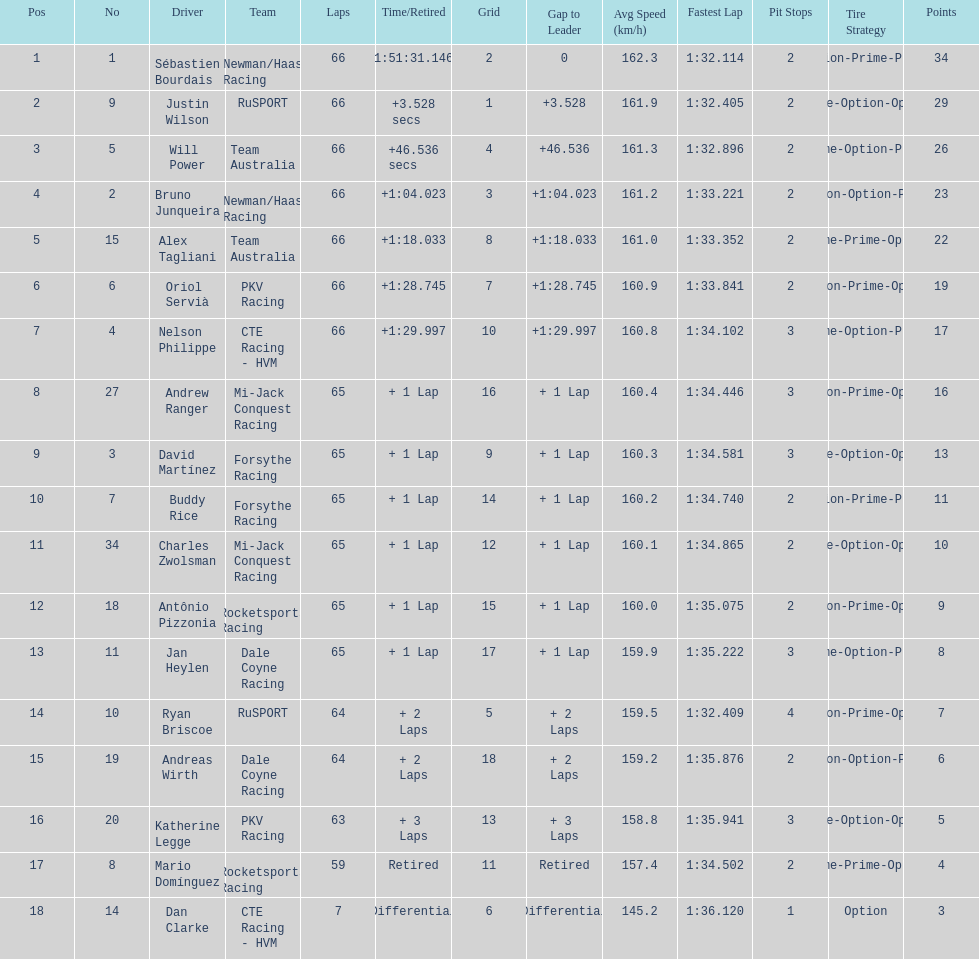How many drivers did not make more than 60 laps? 2. 